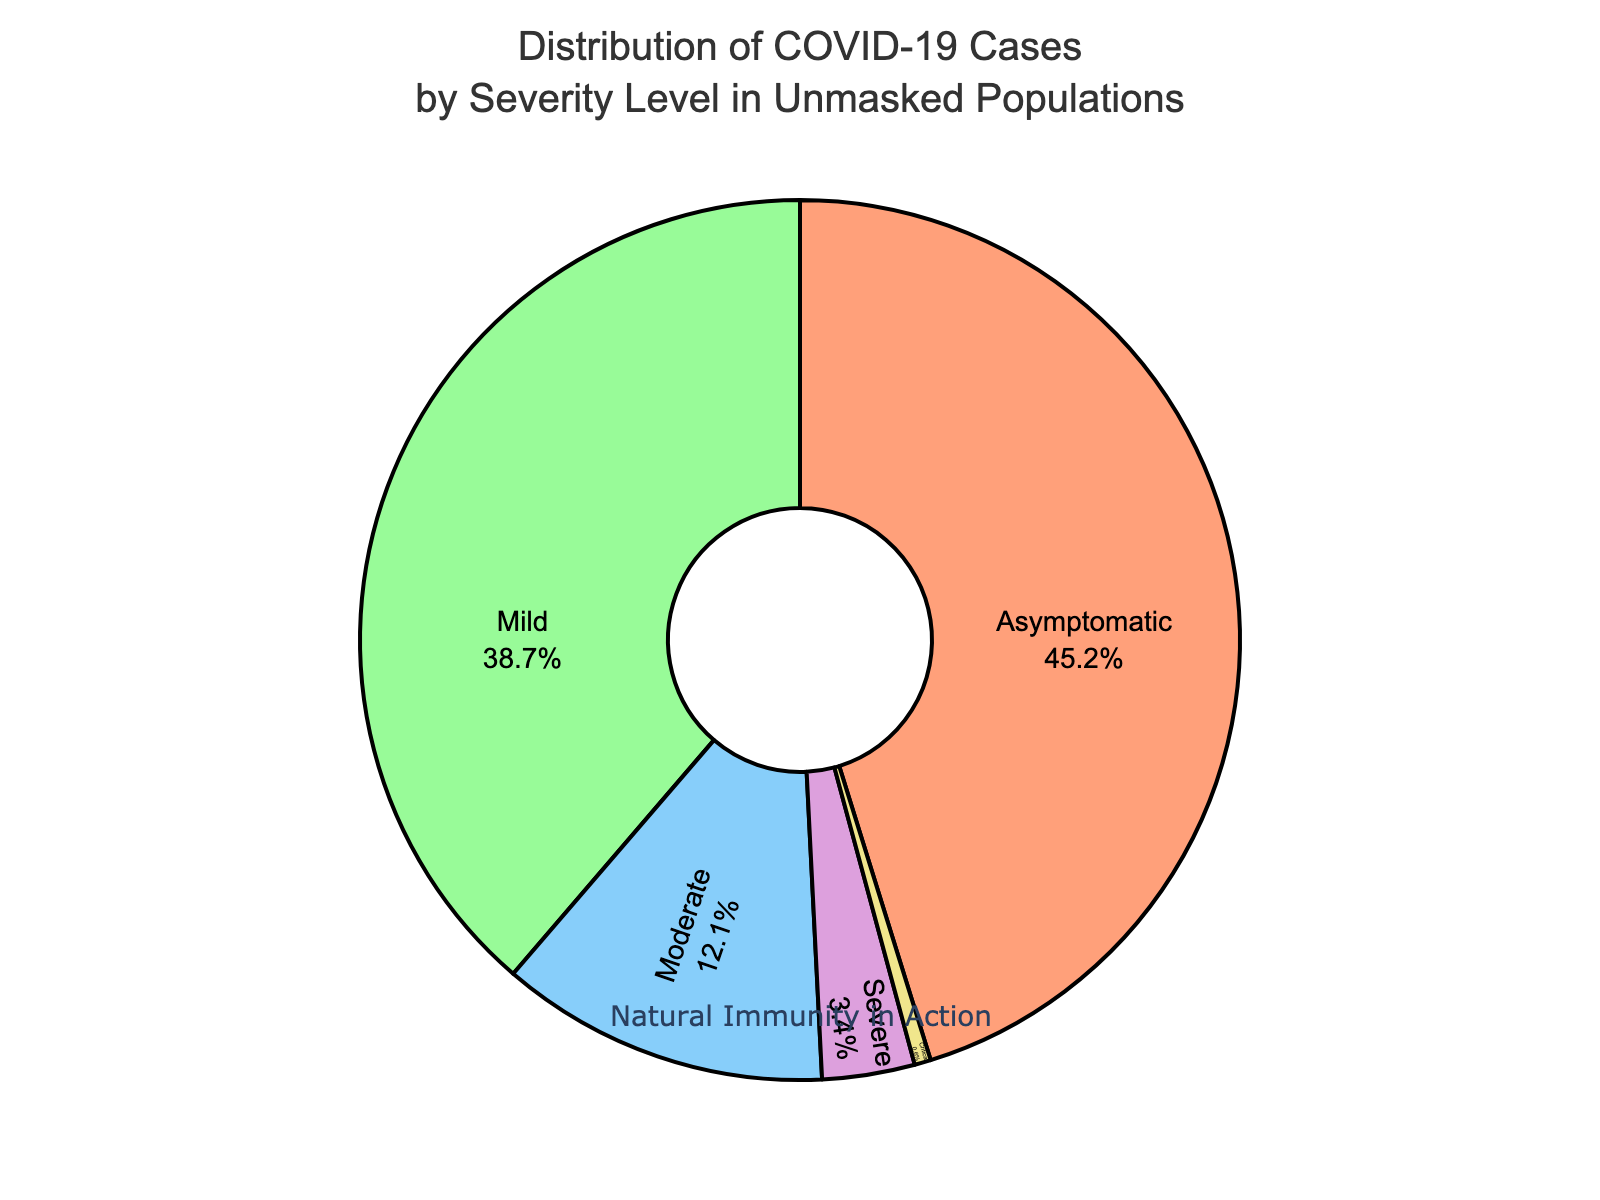What percentage of COVID-19 cases are asymptomatic in unmasked populations? Referring to the pie chart, the segment labeled "Asymptomatic" represents 45.2% of the cases.
Answer: 45.2% Which severity level has the lowest percentage of COVID-19 cases? The pie chart shows different segments for each severity level. The "Critical" segment is the smallest, representing 0.6% of the cases, indicating the lowest percentage.
Answer: Critical What is the combined percentage of cases that are either Severe or Critical? From the pie chart, the percentage of Severe cases is 3.4% and Critical cases is 0.6%. Adding these together: 3.4% + 0.6% = 4%.
Answer: 4% How does the percentage of Mild cases compare to Moderate cases? The pie chart shows that Mild cases are 38.7% and Moderate cases are 12.1%. Comparing these percentages, Mild cases are higher than Moderate cases.
Answer: Mild cases are higher What is the difference between the percentage of Asymptomatic and Severe cases? From the pie chart, Asymptomatic cases are 45.2% and Severe cases are 3.4%. The difference is 45.2% - 3.4% = 41.8%.
Answer: 41.8% What percentage of the cases are neither Mild nor Asymptomatic? From the pie chart, Mild and Asymptomatic cases total 38.7% + 45.2% = 83.9%. Therefore, the percentage not Mild or Asymptomatic is 100% - 83.9% = 16.1%.
Answer: 16.1% If a person believes in natural immunity, what argument could be made from the distribution of the data in this pie chart? One could argue that the high percentage of Asymptomatic (45.2%) and Mild (38.7%) cases supports the idea that many individuals deal with the virus naturally without severe repercussions.
Answer: High Mild and Asymptomatic percentages What does the annotation "Natural Immunity in Action" likely imply in the context of the data shown? The annotation suggests that the high percentages of Asymptomatic and Mild cases reflect the body's natural ability to handle the virus, which proponents of natural immunity might emphasize.
Answer: High natural handling Examining the colors used in the pie chart, which severity level is represented by the light blue color? Observing the pie chart, the light blue color corresponds to the segment labeled "Moderate."
Answer: Moderate What insight can be derived by considering that Severe and Critical cases together constitute a small percentage of the total? Since Severe (3.4%) and Critical (0.6%) cases together only make up 4%, one might infer that serious health implications are relatively rare in the unmasked population according to this data.
Answer: Serious cases are rare 